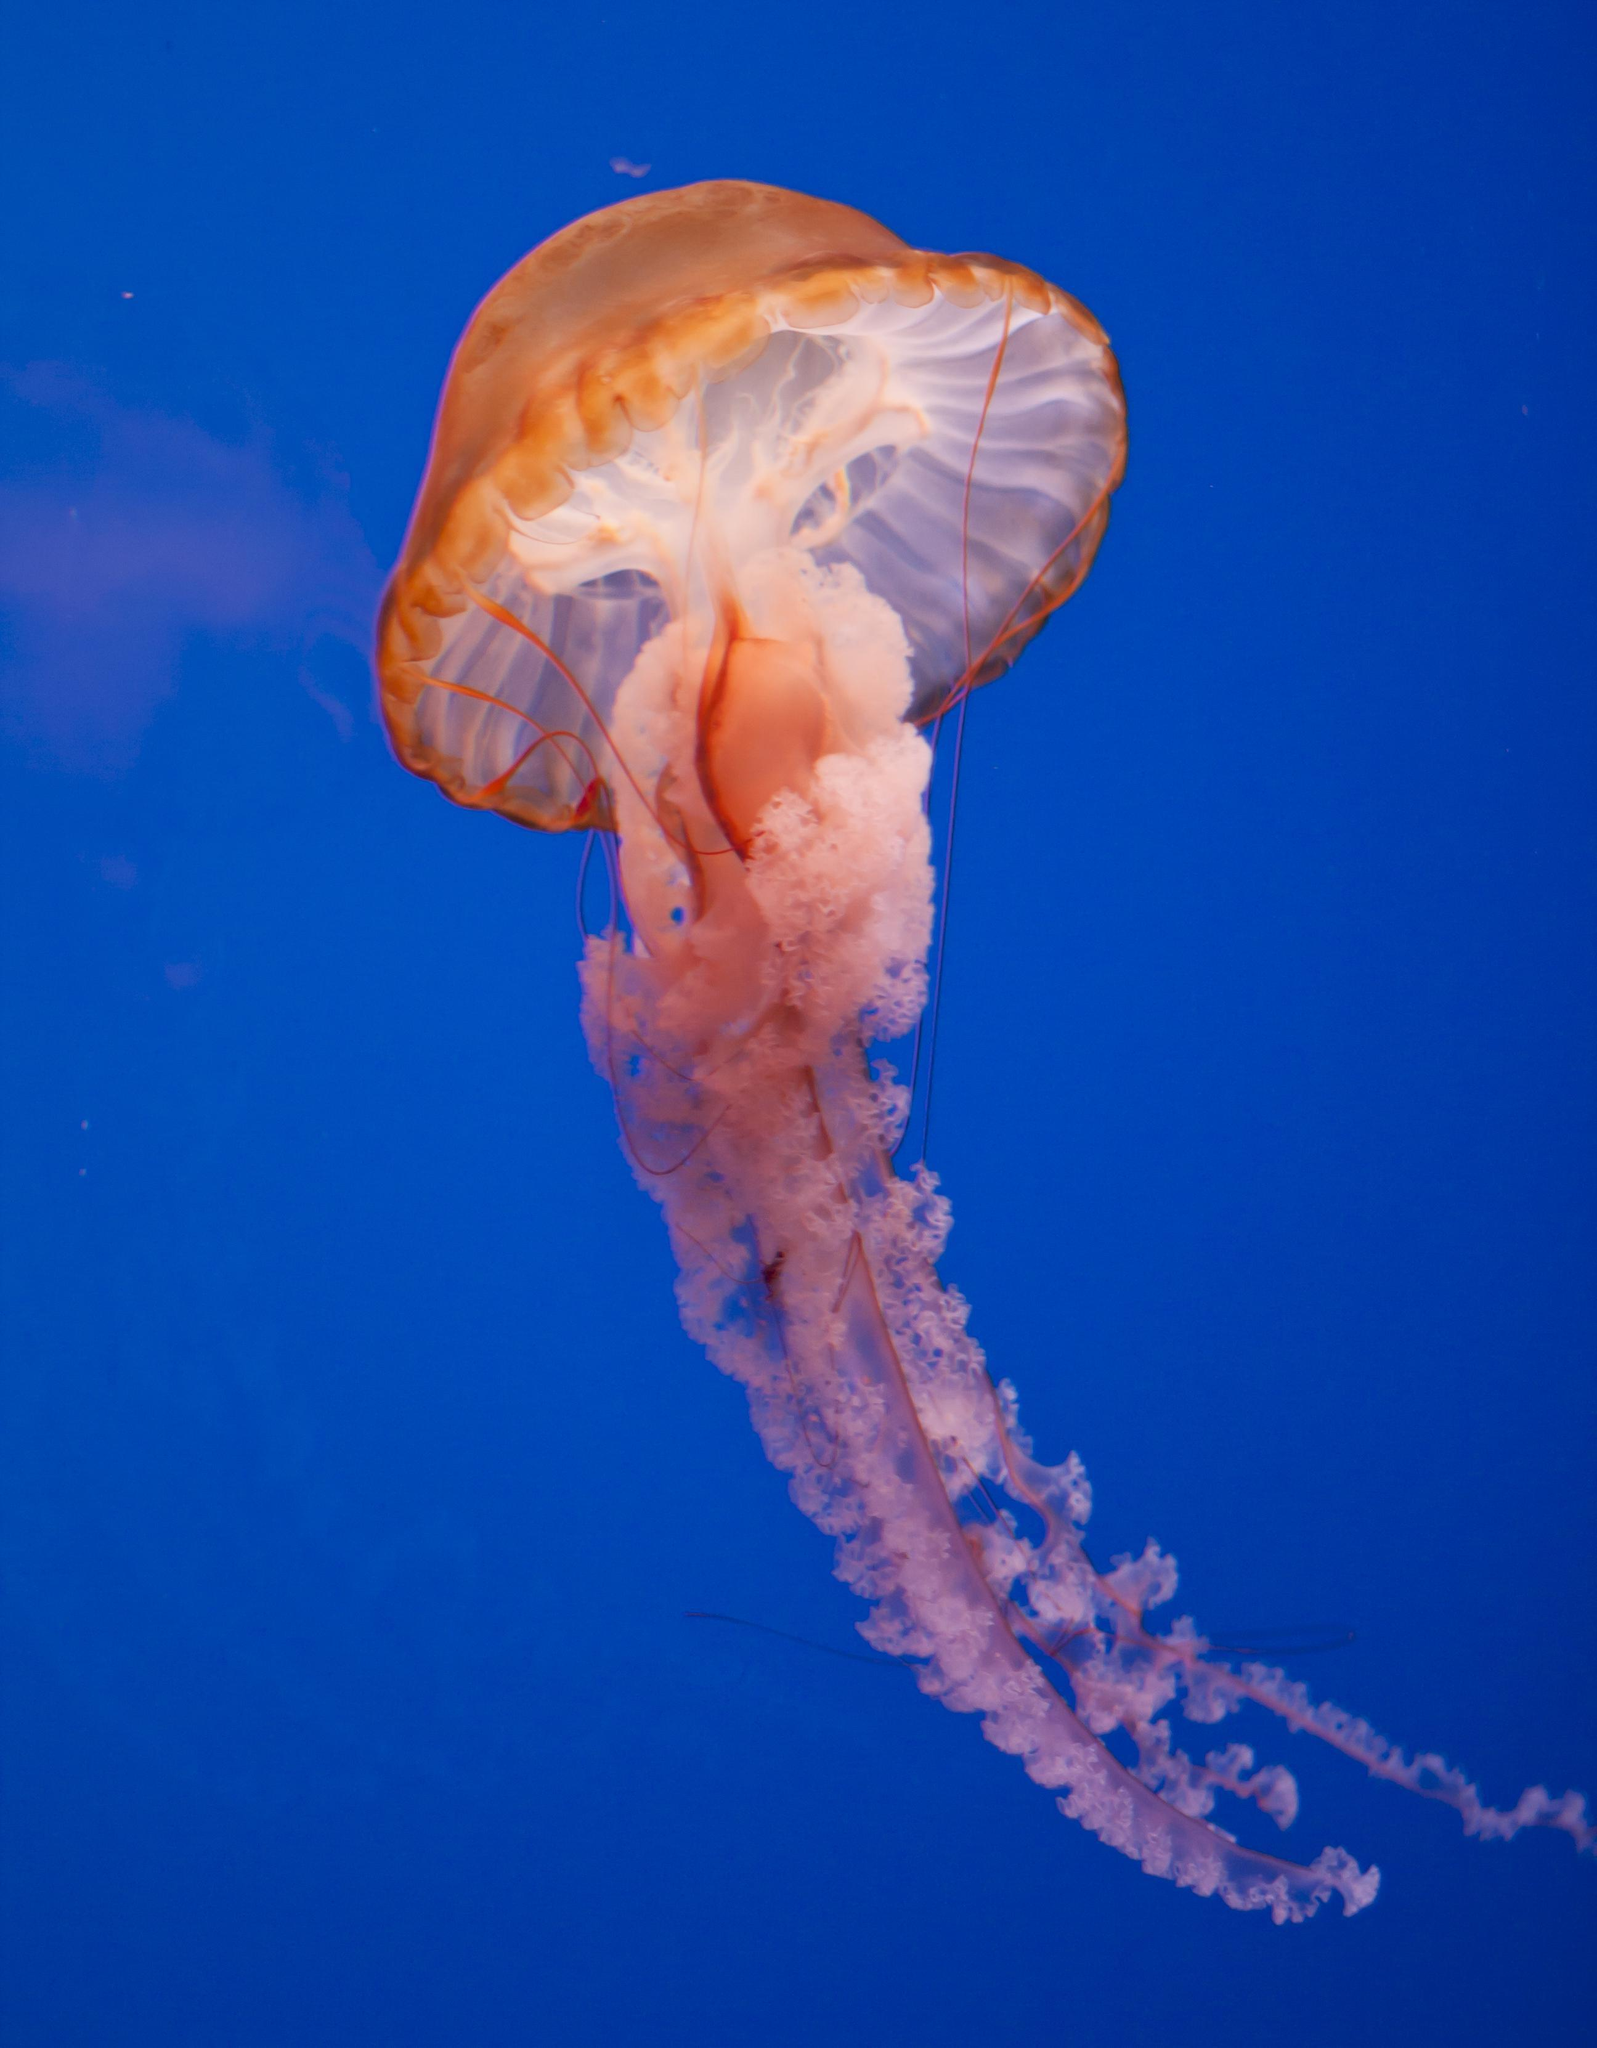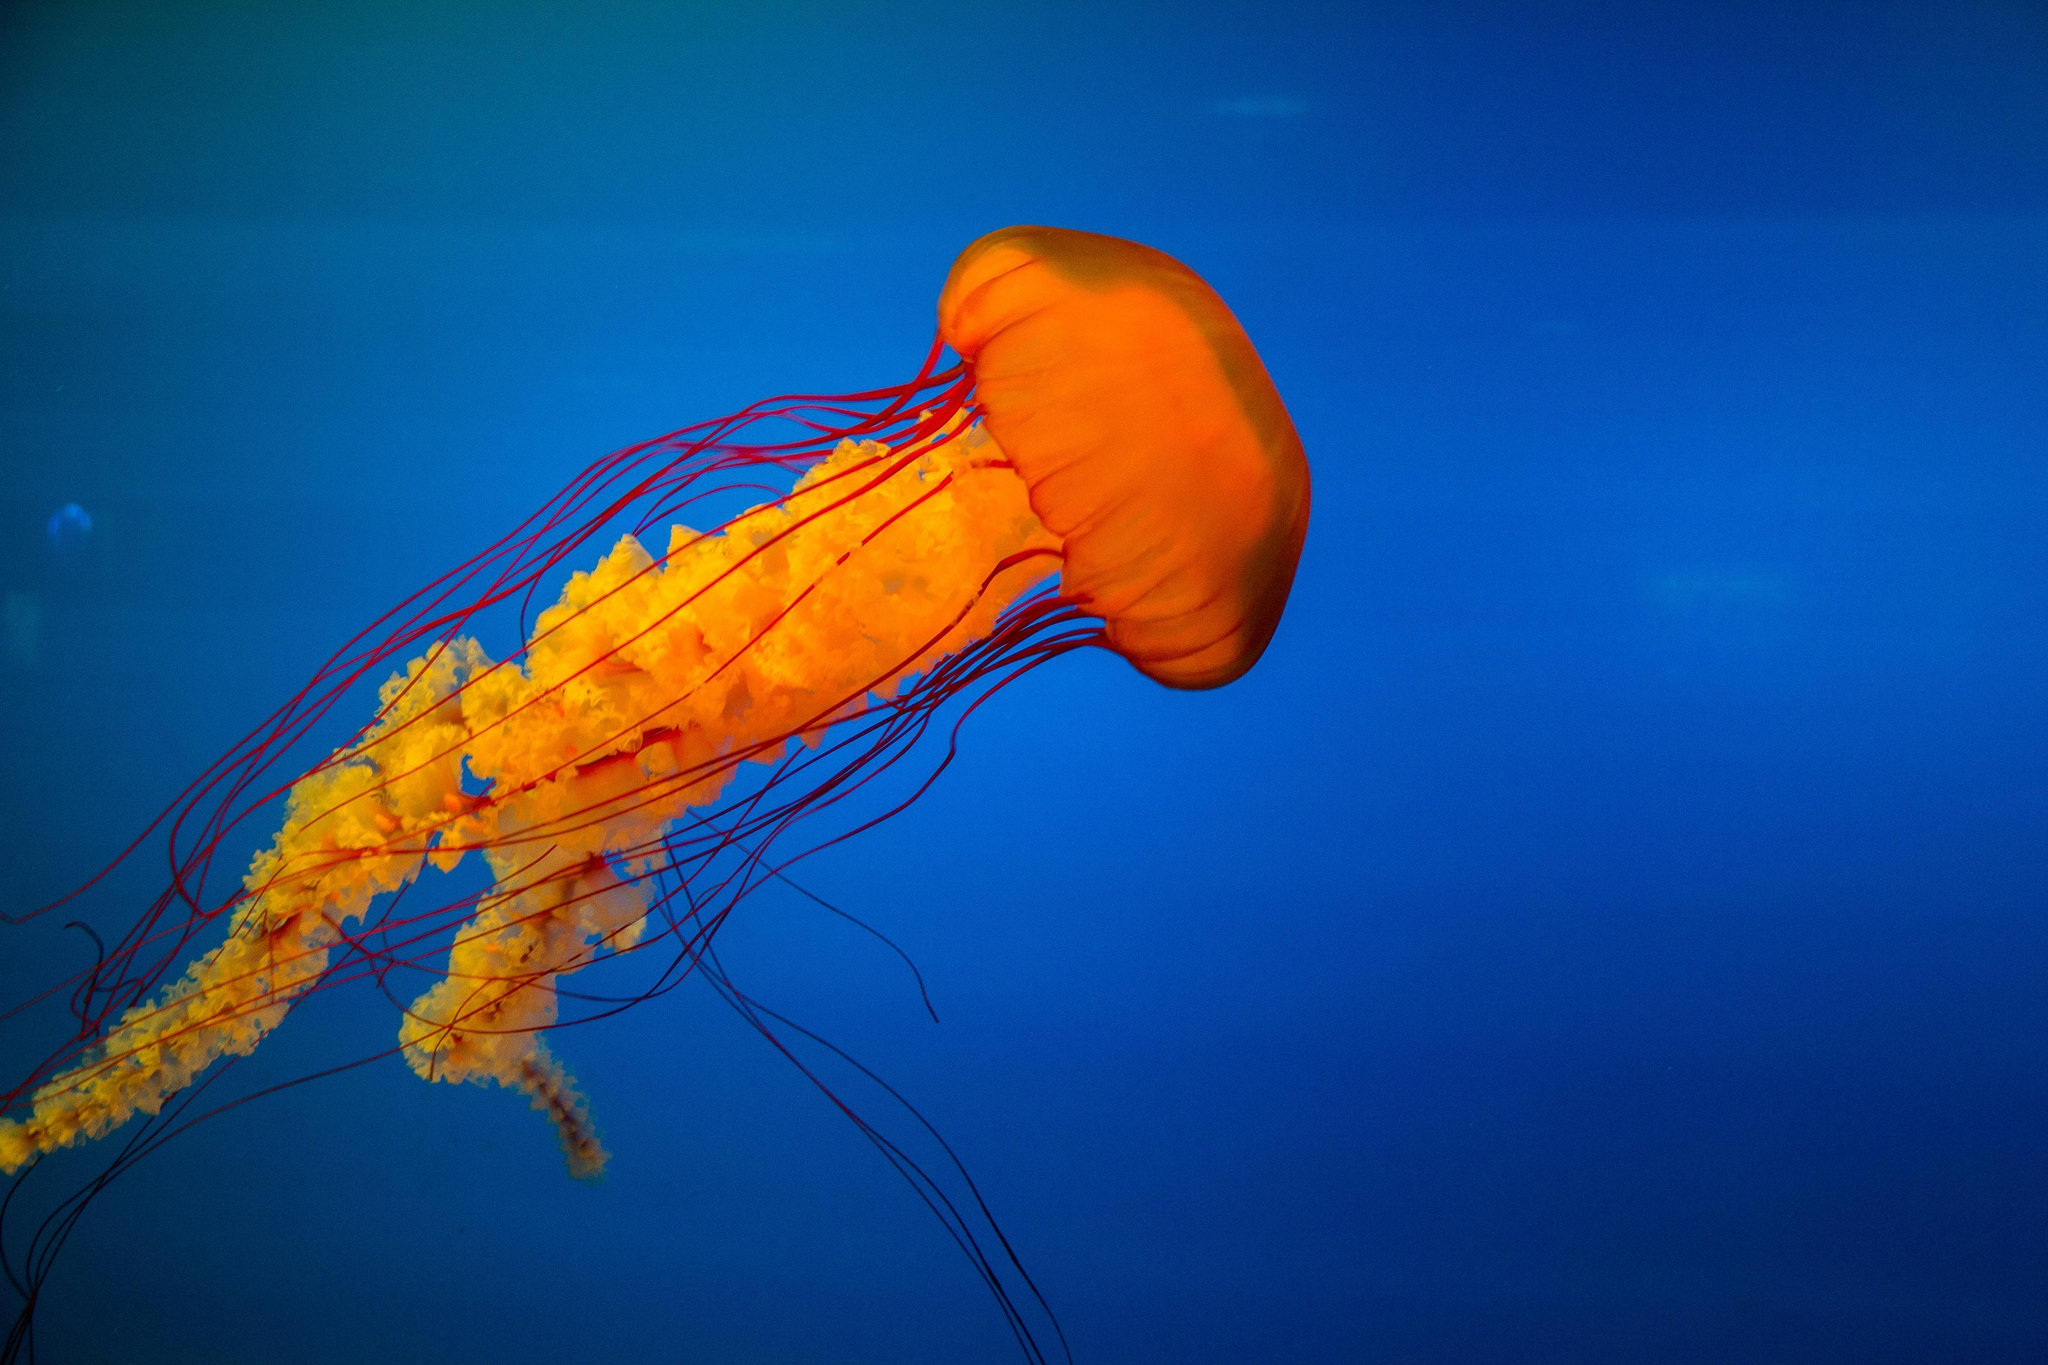The first image is the image on the left, the second image is the image on the right. Considering the images on both sides, is "long thin tendrils extend from an orange jellyfish in one of the images." valid? Answer yes or no. Yes. 